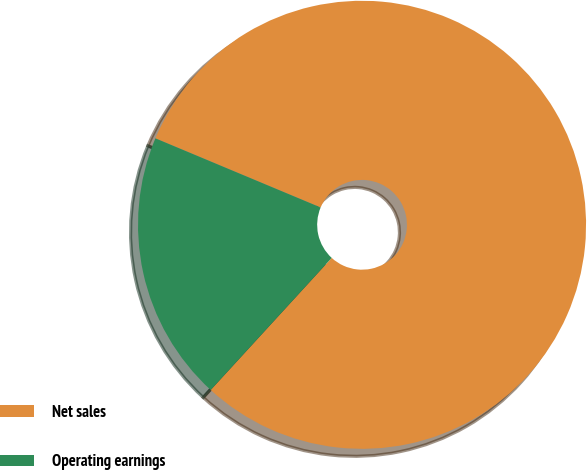<chart> <loc_0><loc_0><loc_500><loc_500><pie_chart><fcel>Net sales<fcel>Operating earnings<nl><fcel>80.5%<fcel>19.5%<nl></chart> 